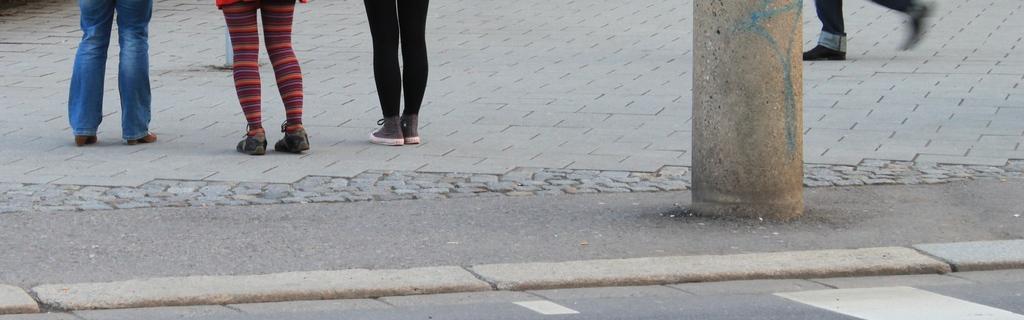Could you give a brief overview of what you see in this image? At the bottom of this image I can see the road. At the top of the image I can see three person's legs on the ground. On the right side, I can see a person is walking and also there is a pillar. 